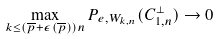Convert formula to latex. <formula><loc_0><loc_0><loc_500><loc_500>\max _ { k \leq ( \overline { p } + \epsilon ( \overline { p } ) ) n } P _ { e , W _ { k , n } } ( C _ { 1 , n } ^ { \perp } ) \to 0</formula> 